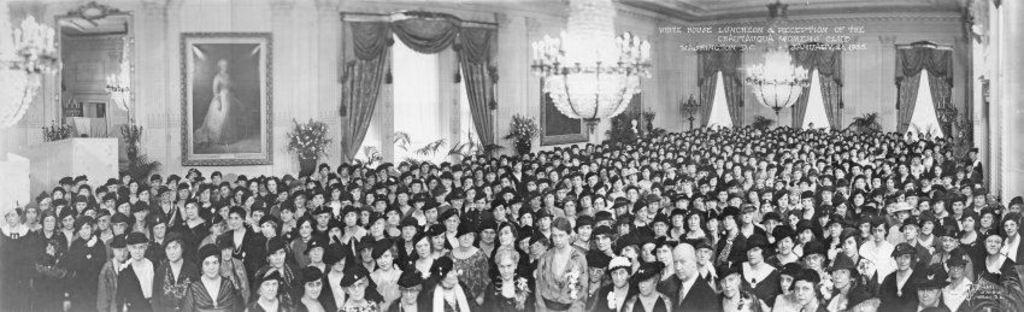Please provide a concise description of this image. This is a black and white image, in this image there are people in a hall, in the background there is a wall to that wall there are curtains and frames at the top there is a chandelier. 